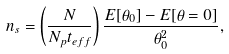<formula> <loc_0><loc_0><loc_500><loc_500>n _ { s } = \left ( \frac { N } { N _ { p } t _ { e f f } } \right ) \frac { E [ \theta _ { 0 } ] - E [ \theta = 0 ] } { \theta _ { 0 } ^ { 2 } } ,</formula> 